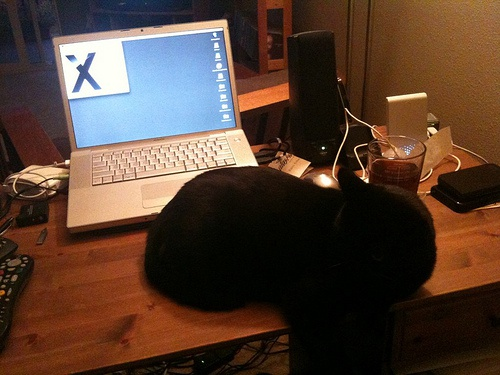Describe the objects in this image and their specific colors. I can see cat in black, maroon, brown, and tan tones, laptop in black, lightblue, ivory, and tan tones, keyboard in black, tan, beige, and gray tones, cup in black, maroon, and brown tones, and cell phone in black, maroon, and brown tones in this image. 